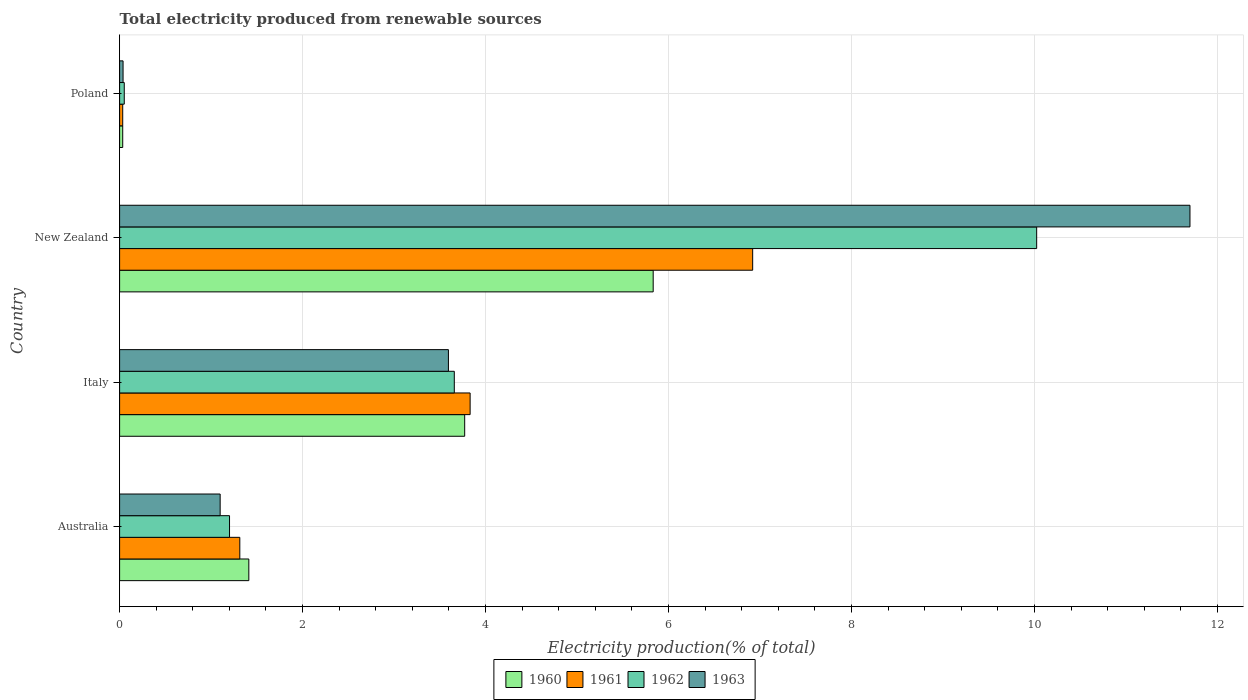How many different coloured bars are there?
Your answer should be very brief. 4. How many groups of bars are there?
Your answer should be very brief. 4. Are the number of bars per tick equal to the number of legend labels?
Keep it short and to the point. Yes. How many bars are there on the 3rd tick from the bottom?
Make the answer very short. 4. What is the label of the 3rd group of bars from the top?
Offer a very short reply. Italy. What is the total electricity produced in 1963 in New Zealand?
Make the answer very short. 11.7. Across all countries, what is the maximum total electricity produced in 1962?
Give a very brief answer. 10.02. Across all countries, what is the minimum total electricity produced in 1962?
Your answer should be very brief. 0.05. In which country was the total electricity produced in 1963 maximum?
Keep it short and to the point. New Zealand. What is the total total electricity produced in 1961 in the graph?
Your response must be concise. 12.1. What is the difference between the total electricity produced in 1960 in Australia and that in Poland?
Keep it short and to the point. 1.38. What is the difference between the total electricity produced in 1963 in Poland and the total electricity produced in 1960 in Australia?
Ensure brevity in your answer.  -1.37. What is the average total electricity produced in 1962 per country?
Ensure brevity in your answer.  3.73. What is the difference between the total electricity produced in 1962 and total electricity produced in 1961 in New Zealand?
Your answer should be very brief. 3.1. In how many countries, is the total electricity produced in 1960 greater than 7.2 %?
Make the answer very short. 0. What is the ratio of the total electricity produced in 1961 in Italy to that in New Zealand?
Ensure brevity in your answer.  0.55. Is the total electricity produced in 1962 in New Zealand less than that in Poland?
Your answer should be very brief. No. What is the difference between the highest and the second highest total electricity produced in 1963?
Your response must be concise. 8.11. What is the difference between the highest and the lowest total electricity produced in 1962?
Your answer should be very brief. 9.97. In how many countries, is the total electricity produced in 1962 greater than the average total electricity produced in 1962 taken over all countries?
Provide a short and direct response. 1. What does the 4th bar from the top in Australia represents?
Offer a terse response. 1960. How many bars are there?
Your answer should be compact. 16. Are all the bars in the graph horizontal?
Offer a very short reply. Yes. What is the difference between two consecutive major ticks on the X-axis?
Give a very brief answer. 2. Are the values on the major ticks of X-axis written in scientific E-notation?
Ensure brevity in your answer.  No. How many legend labels are there?
Keep it short and to the point. 4. What is the title of the graph?
Keep it short and to the point. Total electricity produced from renewable sources. What is the Electricity production(% of total) in 1960 in Australia?
Your answer should be compact. 1.41. What is the Electricity production(% of total) in 1961 in Australia?
Offer a very short reply. 1.31. What is the Electricity production(% of total) of 1962 in Australia?
Offer a terse response. 1.2. What is the Electricity production(% of total) in 1963 in Australia?
Give a very brief answer. 1.1. What is the Electricity production(% of total) in 1960 in Italy?
Make the answer very short. 3.77. What is the Electricity production(% of total) of 1961 in Italy?
Provide a short and direct response. 3.83. What is the Electricity production(% of total) of 1962 in Italy?
Give a very brief answer. 3.66. What is the Electricity production(% of total) in 1963 in Italy?
Keep it short and to the point. 3.59. What is the Electricity production(% of total) in 1960 in New Zealand?
Provide a succinct answer. 5.83. What is the Electricity production(% of total) in 1961 in New Zealand?
Your answer should be compact. 6.92. What is the Electricity production(% of total) of 1962 in New Zealand?
Your answer should be compact. 10.02. What is the Electricity production(% of total) of 1963 in New Zealand?
Offer a terse response. 11.7. What is the Electricity production(% of total) of 1960 in Poland?
Keep it short and to the point. 0.03. What is the Electricity production(% of total) of 1961 in Poland?
Your response must be concise. 0.03. What is the Electricity production(% of total) of 1962 in Poland?
Offer a terse response. 0.05. What is the Electricity production(% of total) in 1963 in Poland?
Offer a very short reply. 0.04. Across all countries, what is the maximum Electricity production(% of total) in 1960?
Your response must be concise. 5.83. Across all countries, what is the maximum Electricity production(% of total) of 1961?
Ensure brevity in your answer.  6.92. Across all countries, what is the maximum Electricity production(% of total) in 1962?
Offer a terse response. 10.02. Across all countries, what is the maximum Electricity production(% of total) in 1963?
Give a very brief answer. 11.7. Across all countries, what is the minimum Electricity production(% of total) in 1960?
Ensure brevity in your answer.  0.03. Across all countries, what is the minimum Electricity production(% of total) in 1961?
Provide a succinct answer. 0.03. Across all countries, what is the minimum Electricity production(% of total) in 1962?
Make the answer very short. 0.05. Across all countries, what is the minimum Electricity production(% of total) in 1963?
Your answer should be compact. 0.04. What is the total Electricity production(% of total) of 1960 in the graph?
Make the answer very short. 11.05. What is the total Electricity production(% of total) in 1961 in the graph?
Offer a very short reply. 12.1. What is the total Electricity production(% of total) in 1962 in the graph?
Ensure brevity in your answer.  14.94. What is the total Electricity production(% of total) of 1963 in the graph?
Ensure brevity in your answer.  16.43. What is the difference between the Electricity production(% of total) of 1960 in Australia and that in Italy?
Your answer should be very brief. -2.36. What is the difference between the Electricity production(% of total) of 1961 in Australia and that in Italy?
Keep it short and to the point. -2.52. What is the difference between the Electricity production(% of total) in 1962 in Australia and that in Italy?
Make the answer very short. -2.46. What is the difference between the Electricity production(% of total) of 1963 in Australia and that in Italy?
Your response must be concise. -2.5. What is the difference between the Electricity production(% of total) of 1960 in Australia and that in New Zealand?
Provide a short and direct response. -4.42. What is the difference between the Electricity production(% of total) in 1961 in Australia and that in New Zealand?
Keep it short and to the point. -5.61. What is the difference between the Electricity production(% of total) in 1962 in Australia and that in New Zealand?
Make the answer very short. -8.82. What is the difference between the Electricity production(% of total) in 1963 in Australia and that in New Zealand?
Your answer should be very brief. -10.6. What is the difference between the Electricity production(% of total) of 1960 in Australia and that in Poland?
Provide a succinct answer. 1.38. What is the difference between the Electricity production(% of total) of 1961 in Australia and that in Poland?
Give a very brief answer. 1.28. What is the difference between the Electricity production(% of total) of 1962 in Australia and that in Poland?
Offer a very short reply. 1.15. What is the difference between the Electricity production(% of total) in 1963 in Australia and that in Poland?
Offer a terse response. 1.06. What is the difference between the Electricity production(% of total) of 1960 in Italy and that in New Zealand?
Your answer should be compact. -2.06. What is the difference between the Electricity production(% of total) of 1961 in Italy and that in New Zealand?
Offer a terse response. -3.09. What is the difference between the Electricity production(% of total) of 1962 in Italy and that in New Zealand?
Ensure brevity in your answer.  -6.37. What is the difference between the Electricity production(% of total) in 1963 in Italy and that in New Zealand?
Ensure brevity in your answer.  -8.11. What is the difference between the Electricity production(% of total) of 1960 in Italy and that in Poland?
Give a very brief answer. 3.74. What is the difference between the Electricity production(% of total) of 1961 in Italy and that in Poland?
Your answer should be compact. 3.8. What is the difference between the Electricity production(% of total) in 1962 in Italy and that in Poland?
Your response must be concise. 3.61. What is the difference between the Electricity production(% of total) of 1963 in Italy and that in Poland?
Give a very brief answer. 3.56. What is the difference between the Electricity production(% of total) in 1960 in New Zealand and that in Poland?
Give a very brief answer. 5.8. What is the difference between the Electricity production(% of total) of 1961 in New Zealand and that in Poland?
Give a very brief answer. 6.89. What is the difference between the Electricity production(% of total) of 1962 in New Zealand and that in Poland?
Make the answer very short. 9.97. What is the difference between the Electricity production(% of total) in 1963 in New Zealand and that in Poland?
Your answer should be very brief. 11.66. What is the difference between the Electricity production(% of total) of 1960 in Australia and the Electricity production(% of total) of 1961 in Italy?
Your response must be concise. -2.42. What is the difference between the Electricity production(% of total) in 1960 in Australia and the Electricity production(% of total) in 1962 in Italy?
Give a very brief answer. -2.25. What is the difference between the Electricity production(% of total) in 1960 in Australia and the Electricity production(% of total) in 1963 in Italy?
Your answer should be compact. -2.18. What is the difference between the Electricity production(% of total) in 1961 in Australia and the Electricity production(% of total) in 1962 in Italy?
Your answer should be compact. -2.34. What is the difference between the Electricity production(% of total) in 1961 in Australia and the Electricity production(% of total) in 1963 in Italy?
Provide a short and direct response. -2.28. What is the difference between the Electricity production(% of total) of 1962 in Australia and the Electricity production(% of total) of 1963 in Italy?
Your response must be concise. -2.39. What is the difference between the Electricity production(% of total) in 1960 in Australia and the Electricity production(% of total) in 1961 in New Zealand?
Your response must be concise. -5.51. What is the difference between the Electricity production(% of total) in 1960 in Australia and the Electricity production(% of total) in 1962 in New Zealand?
Provide a short and direct response. -8.61. What is the difference between the Electricity production(% of total) in 1960 in Australia and the Electricity production(% of total) in 1963 in New Zealand?
Offer a very short reply. -10.29. What is the difference between the Electricity production(% of total) of 1961 in Australia and the Electricity production(% of total) of 1962 in New Zealand?
Give a very brief answer. -8.71. What is the difference between the Electricity production(% of total) of 1961 in Australia and the Electricity production(% of total) of 1963 in New Zealand?
Your answer should be compact. -10.39. What is the difference between the Electricity production(% of total) of 1962 in Australia and the Electricity production(% of total) of 1963 in New Zealand?
Your response must be concise. -10.5. What is the difference between the Electricity production(% of total) in 1960 in Australia and the Electricity production(% of total) in 1961 in Poland?
Offer a very short reply. 1.38. What is the difference between the Electricity production(% of total) in 1960 in Australia and the Electricity production(% of total) in 1962 in Poland?
Offer a terse response. 1.36. What is the difference between the Electricity production(% of total) in 1960 in Australia and the Electricity production(% of total) in 1963 in Poland?
Ensure brevity in your answer.  1.37. What is the difference between the Electricity production(% of total) of 1961 in Australia and the Electricity production(% of total) of 1962 in Poland?
Make the answer very short. 1.26. What is the difference between the Electricity production(% of total) of 1961 in Australia and the Electricity production(% of total) of 1963 in Poland?
Make the answer very short. 1.28. What is the difference between the Electricity production(% of total) in 1962 in Australia and the Electricity production(% of total) in 1963 in Poland?
Provide a succinct answer. 1.16. What is the difference between the Electricity production(% of total) in 1960 in Italy and the Electricity production(% of total) in 1961 in New Zealand?
Keep it short and to the point. -3.15. What is the difference between the Electricity production(% of total) in 1960 in Italy and the Electricity production(% of total) in 1962 in New Zealand?
Offer a terse response. -6.25. What is the difference between the Electricity production(% of total) in 1960 in Italy and the Electricity production(% of total) in 1963 in New Zealand?
Ensure brevity in your answer.  -7.93. What is the difference between the Electricity production(% of total) in 1961 in Italy and the Electricity production(% of total) in 1962 in New Zealand?
Provide a succinct answer. -6.19. What is the difference between the Electricity production(% of total) in 1961 in Italy and the Electricity production(% of total) in 1963 in New Zealand?
Keep it short and to the point. -7.87. What is the difference between the Electricity production(% of total) in 1962 in Italy and the Electricity production(% of total) in 1963 in New Zealand?
Provide a succinct answer. -8.04. What is the difference between the Electricity production(% of total) in 1960 in Italy and the Electricity production(% of total) in 1961 in Poland?
Keep it short and to the point. 3.74. What is the difference between the Electricity production(% of total) in 1960 in Italy and the Electricity production(% of total) in 1962 in Poland?
Give a very brief answer. 3.72. What is the difference between the Electricity production(% of total) in 1960 in Italy and the Electricity production(% of total) in 1963 in Poland?
Offer a very short reply. 3.73. What is the difference between the Electricity production(% of total) of 1961 in Italy and the Electricity production(% of total) of 1962 in Poland?
Your response must be concise. 3.78. What is the difference between the Electricity production(% of total) of 1961 in Italy and the Electricity production(% of total) of 1963 in Poland?
Offer a very short reply. 3.79. What is the difference between the Electricity production(% of total) of 1962 in Italy and the Electricity production(% of total) of 1963 in Poland?
Keep it short and to the point. 3.62. What is the difference between the Electricity production(% of total) in 1960 in New Zealand and the Electricity production(% of total) in 1961 in Poland?
Ensure brevity in your answer.  5.8. What is the difference between the Electricity production(% of total) in 1960 in New Zealand and the Electricity production(% of total) in 1962 in Poland?
Make the answer very short. 5.78. What is the difference between the Electricity production(% of total) of 1960 in New Zealand and the Electricity production(% of total) of 1963 in Poland?
Your answer should be very brief. 5.79. What is the difference between the Electricity production(% of total) in 1961 in New Zealand and the Electricity production(% of total) in 1962 in Poland?
Provide a succinct answer. 6.87. What is the difference between the Electricity production(% of total) in 1961 in New Zealand and the Electricity production(% of total) in 1963 in Poland?
Provide a short and direct response. 6.88. What is the difference between the Electricity production(% of total) in 1962 in New Zealand and the Electricity production(% of total) in 1963 in Poland?
Your answer should be very brief. 9.99. What is the average Electricity production(% of total) in 1960 per country?
Your answer should be compact. 2.76. What is the average Electricity production(% of total) of 1961 per country?
Provide a short and direct response. 3.02. What is the average Electricity production(% of total) in 1962 per country?
Provide a short and direct response. 3.73. What is the average Electricity production(% of total) of 1963 per country?
Your answer should be compact. 4.11. What is the difference between the Electricity production(% of total) of 1960 and Electricity production(% of total) of 1961 in Australia?
Keep it short and to the point. 0.1. What is the difference between the Electricity production(% of total) of 1960 and Electricity production(% of total) of 1962 in Australia?
Provide a short and direct response. 0.21. What is the difference between the Electricity production(% of total) of 1960 and Electricity production(% of total) of 1963 in Australia?
Offer a terse response. 0.31. What is the difference between the Electricity production(% of total) in 1961 and Electricity production(% of total) in 1962 in Australia?
Ensure brevity in your answer.  0.11. What is the difference between the Electricity production(% of total) in 1961 and Electricity production(% of total) in 1963 in Australia?
Offer a very short reply. 0.21. What is the difference between the Electricity production(% of total) of 1962 and Electricity production(% of total) of 1963 in Australia?
Ensure brevity in your answer.  0.1. What is the difference between the Electricity production(% of total) of 1960 and Electricity production(% of total) of 1961 in Italy?
Provide a succinct answer. -0.06. What is the difference between the Electricity production(% of total) of 1960 and Electricity production(% of total) of 1962 in Italy?
Make the answer very short. 0.11. What is the difference between the Electricity production(% of total) of 1960 and Electricity production(% of total) of 1963 in Italy?
Keep it short and to the point. 0.18. What is the difference between the Electricity production(% of total) of 1961 and Electricity production(% of total) of 1962 in Italy?
Give a very brief answer. 0.17. What is the difference between the Electricity production(% of total) in 1961 and Electricity production(% of total) in 1963 in Italy?
Offer a very short reply. 0.24. What is the difference between the Electricity production(% of total) of 1962 and Electricity production(% of total) of 1963 in Italy?
Offer a terse response. 0.06. What is the difference between the Electricity production(% of total) of 1960 and Electricity production(% of total) of 1961 in New Zealand?
Keep it short and to the point. -1.09. What is the difference between the Electricity production(% of total) in 1960 and Electricity production(% of total) in 1962 in New Zealand?
Give a very brief answer. -4.19. What is the difference between the Electricity production(% of total) of 1960 and Electricity production(% of total) of 1963 in New Zealand?
Your response must be concise. -5.87. What is the difference between the Electricity production(% of total) in 1961 and Electricity production(% of total) in 1962 in New Zealand?
Offer a terse response. -3.1. What is the difference between the Electricity production(% of total) of 1961 and Electricity production(% of total) of 1963 in New Zealand?
Offer a terse response. -4.78. What is the difference between the Electricity production(% of total) of 1962 and Electricity production(% of total) of 1963 in New Zealand?
Your response must be concise. -1.68. What is the difference between the Electricity production(% of total) of 1960 and Electricity production(% of total) of 1961 in Poland?
Offer a very short reply. 0. What is the difference between the Electricity production(% of total) in 1960 and Electricity production(% of total) in 1962 in Poland?
Offer a very short reply. -0.02. What is the difference between the Electricity production(% of total) in 1960 and Electricity production(% of total) in 1963 in Poland?
Your answer should be very brief. -0. What is the difference between the Electricity production(% of total) in 1961 and Electricity production(% of total) in 1962 in Poland?
Keep it short and to the point. -0.02. What is the difference between the Electricity production(% of total) in 1961 and Electricity production(% of total) in 1963 in Poland?
Keep it short and to the point. -0. What is the difference between the Electricity production(% of total) in 1962 and Electricity production(% of total) in 1963 in Poland?
Your answer should be compact. 0.01. What is the ratio of the Electricity production(% of total) of 1960 in Australia to that in Italy?
Your answer should be very brief. 0.37. What is the ratio of the Electricity production(% of total) of 1961 in Australia to that in Italy?
Provide a succinct answer. 0.34. What is the ratio of the Electricity production(% of total) of 1962 in Australia to that in Italy?
Your answer should be compact. 0.33. What is the ratio of the Electricity production(% of total) in 1963 in Australia to that in Italy?
Offer a terse response. 0.31. What is the ratio of the Electricity production(% of total) in 1960 in Australia to that in New Zealand?
Your response must be concise. 0.24. What is the ratio of the Electricity production(% of total) of 1961 in Australia to that in New Zealand?
Keep it short and to the point. 0.19. What is the ratio of the Electricity production(% of total) in 1962 in Australia to that in New Zealand?
Provide a short and direct response. 0.12. What is the ratio of the Electricity production(% of total) of 1963 in Australia to that in New Zealand?
Provide a succinct answer. 0.09. What is the ratio of the Electricity production(% of total) of 1960 in Australia to that in Poland?
Your answer should be very brief. 41.37. What is the ratio of the Electricity production(% of total) of 1961 in Australia to that in Poland?
Offer a very short reply. 38.51. What is the ratio of the Electricity production(% of total) of 1962 in Australia to that in Poland?
Ensure brevity in your answer.  23.61. What is the ratio of the Electricity production(% of total) in 1963 in Australia to that in Poland?
Your response must be concise. 29. What is the ratio of the Electricity production(% of total) of 1960 in Italy to that in New Zealand?
Provide a succinct answer. 0.65. What is the ratio of the Electricity production(% of total) of 1961 in Italy to that in New Zealand?
Give a very brief answer. 0.55. What is the ratio of the Electricity production(% of total) of 1962 in Italy to that in New Zealand?
Give a very brief answer. 0.36. What is the ratio of the Electricity production(% of total) in 1963 in Italy to that in New Zealand?
Offer a terse response. 0.31. What is the ratio of the Electricity production(% of total) of 1960 in Italy to that in Poland?
Your response must be concise. 110.45. What is the ratio of the Electricity production(% of total) of 1961 in Italy to that in Poland?
Give a very brief answer. 112.3. What is the ratio of the Electricity production(% of total) of 1962 in Italy to that in Poland?
Keep it short and to the point. 71.88. What is the ratio of the Electricity production(% of total) in 1963 in Italy to that in Poland?
Ensure brevity in your answer.  94.84. What is the ratio of the Electricity production(% of total) of 1960 in New Zealand to that in Poland?
Your response must be concise. 170.79. What is the ratio of the Electricity production(% of total) in 1961 in New Zealand to that in Poland?
Your response must be concise. 202.83. What is the ratio of the Electricity production(% of total) of 1962 in New Zealand to that in Poland?
Ensure brevity in your answer.  196.95. What is the ratio of the Electricity production(% of total) of 1963 in New Zealand to that in Poland?
Your answer should be compact. 308.73. What is the difference between the highest and the second highest Electricity production(% of total) in 1960?
Offer a terse response. 2.06. What is the difference between the highest and the second highest Electricity production(% of total) of 1961?
Ensure brevity in your answer.  3.09. What is the difference between the highest and the second highest Electricity production(% of total) of 1962?
Offer a very short reply. 6.37. What is the difference between the highest and the second highest Electricity production(% of total) of 1963?
Make the answer very short. 8.11. What is the difference between the highest and the lowest Electricity production(% of total) of 1960?
Ensure brevity in your answer.  5.8. What is the difference between the highest and the lowest Electricity production(% of total) of 1961?
Give a very brief answer. 6.89. What is the difference between the highest and the lowest Electricity production(% of total) in 1962?
Give a very brief answer. 9.97. What is the difference between the highest and the lowest Electricity production(% of total) in 1963?
Your answer should be very brief. 11.66. 